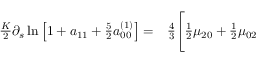<formula> <loc_0><loc_0><loc_500><loc_500>\begin{array} { r l } { \frac { K } { 2 } \partial _ { s } \ln \left [ 1 + a _ { 1 1 } + \frac { 5 } { 2 } a _ { 0 0 } ^ { ( 1 ) } \right ] = } & \frac { 4 } { 3 } \Big [ \frac { 1 } { 2 } \mu _ { 2 0 } + \frac { 1 } { 2 } \mu _ { 0 2 } } \end{array}</formula> 